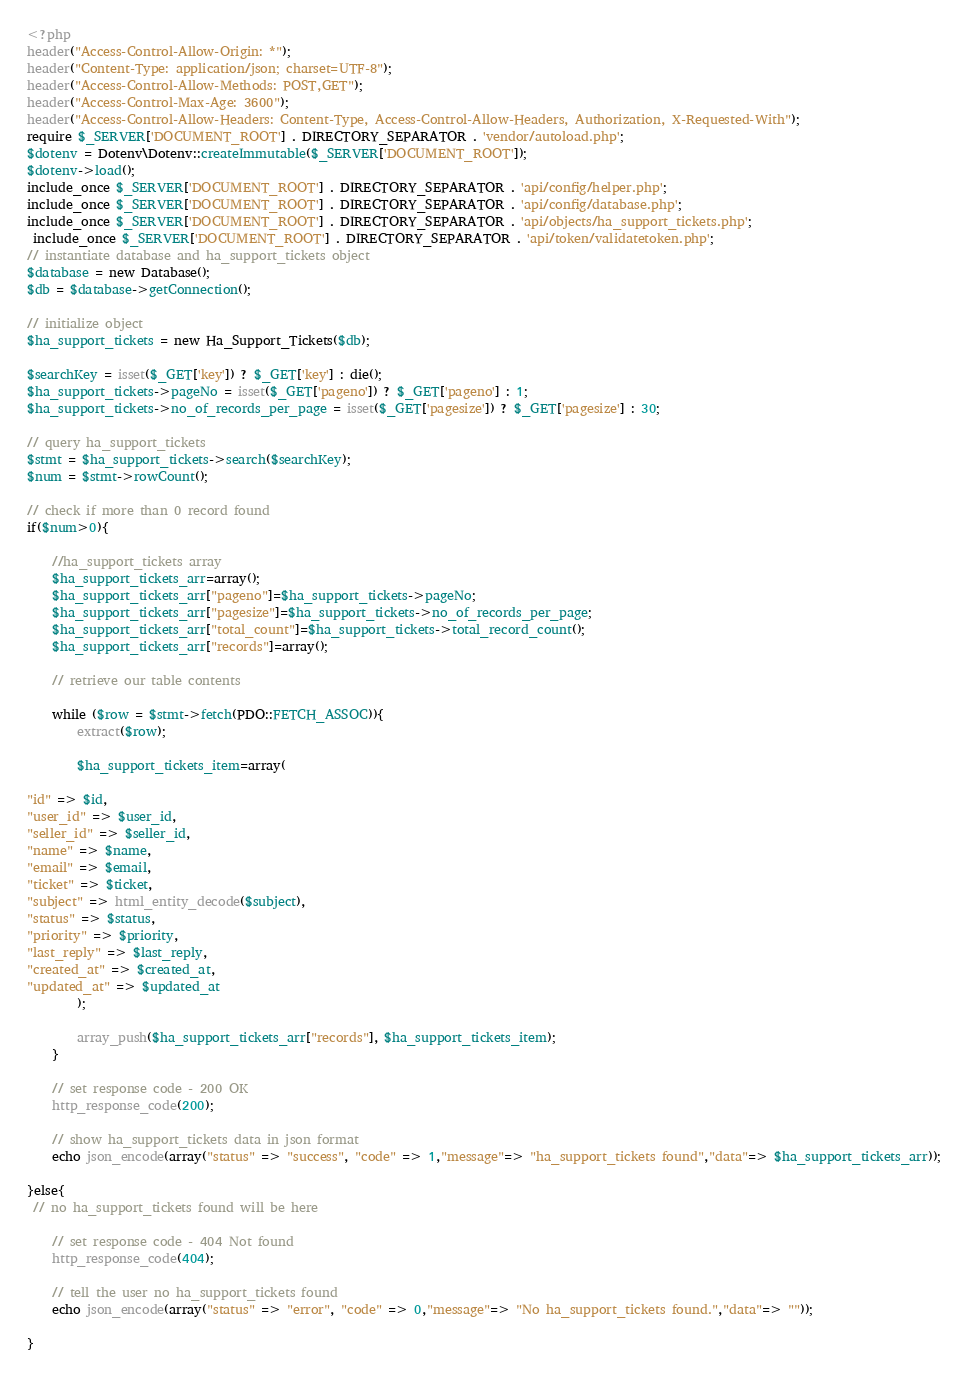Convert code to text. <code><loc_0><loc_0><loc_500><loc_500><_PHP_><?php
header("Access-Control-Allow-Origin: *");
header("Content-Type: application/json; charset=UTF-8");
header("Access-Control-Allow-Methods: POST,GET");
header("Access-Control-Max-Age: 3600");
header("Access-Control-Allow-Headers: Content-Type, Access-Control-Allow-Headers, Authorization, X-Requested-With");
require $_SERVER['DOCUMENT_ROOT'] . DIRECTORY_SEPARATOR . 'vendor/autoload.php';
$dotenv = Dotenv\Dotenv::createImmutable($_SERVER['DOCUMENT_ROOT']);
$dotenv->load();
include_once $_SERVER['DOCUMENT_ROOT'] . DIRECTORY_SEPARATOR . 'api/config/helper.php';
include_once $_SERVER['DOCUMENT_ROOT'] . DIRECTORY_SEPARATOR . 'api/config/database.php';
include_once $_SERVER['DOCUMENT_ROOT'] . DIRECTORY_SEPARATOR . 'api/objects/ha_support_tickets.php';
 include_once $_SERVER['DOCUMENT_ROOT'] . DIRECTORY_SEPARATOR . 'api/token/validatetoken.php';
// instantiate database and ha_support_tickets object
$database = new Database();
$db = $database->getConnection();
 
// initialize object
$ha_support_tickets = new Ha_Support_Tickets($db);

$searchKey = isset($_GET['key']) ? $_GET['key'] : die();
$ha_support_tickets->pageNo = isset($_GET['pageno']) ? $_GET['pageno'] : 1;
$ha_support_tickets->no_of_records_per_page = isset($_GET['pagesize']) ? $_GET['pagesize'] : 30;

// query ha_support_tickets
$stmt = $ha_support_tickets->search($searchKey);
$num = $stmt->rowCount();
 
// check if more than 0 record found
if($num>0){
 
    //ha_support_tickets array
    $ha_support_tickets_arr=array();
	$ha_support_tickets_arr["pageno"]=$ha_support_tickets->pageNo;
	$ha_support_tickets_arr["pagesize"]=$ha_support_tickets->no_of_records_per_page;
    $ha_support_tickets_arr["total_count"]=$ha_support_tickets->total_record_count();
    $ha_support_tickets_arr["records"]=array();
 
    // retrieve our table contents
    
    while ($row = $stmt->fetch(PDO::FETCH_ASSOC)){
        extract($row);
 
        $ha_support_tickets_item=array(
            
"id" => $id,
"user_id" => $user_id,
"seller_id" => $seller_id,
"name" => $name,
"email" => $email,
"ticket" => $ticket,
"subject" => html_entity_decode($subject),
"status" => $status,
"priority" => $priority,
"last_reply" => $last_reply,
"created_at" => $created_at,
"updated_at" => $updated_at
        );
 
        array_push($ha_support_tickets_arr["records"], $ha_support_tickets_item);
    }
 
    // set response code - 200 OK
    http_response_code(200);
 
    // show ha_support_tickets data in json format
	echo json_encode(array("status" => "success", "code" => 1,"message"=> "ha_support_tickets found","data"=> $ha_support_tickets_arr));
    
}else{
 // no ha_support_tickets found will be here

    // set response code - 404 Not found
    http_response_code(404);
 
    // tell the user no ha_support_tickets found
	echo json_encode(array("status" => "error", "code" => 0,"message"=> "No ha_support_tickets found.","data"=> ""));
    
}
 


</code> 